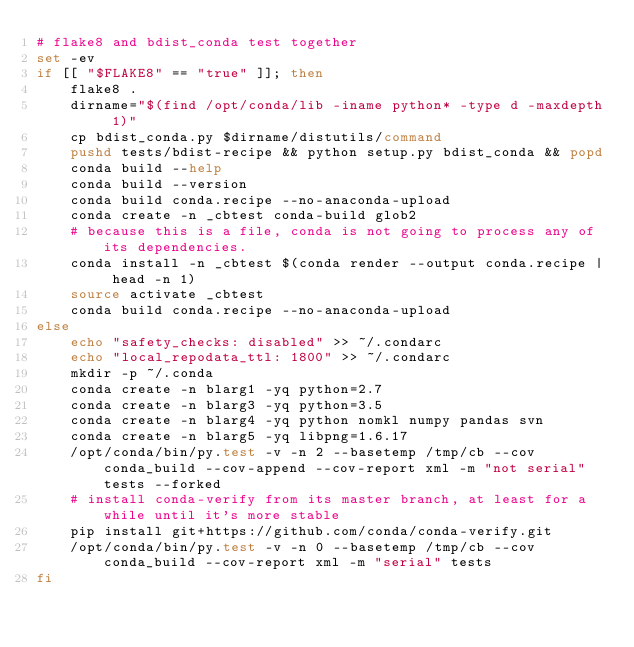Convert code to text. <code><loc_0><loc_0><loc_500><loc_500><_Bash_># flake8 and bdist_conda test together
set -ev
if [[ "$FLAKE8" == "true" ]]; then
    flake8 .
    dirname="$(find /opt/conda/lib -iname python* -type d -maxdepth 1)"
    cp bdist_conda.py $dirname/distutils/command
    pushd tests/bdist-recipe && python setup.py bdist_conda && popd
    conda build --help
    conda build --version
    conda build conda.recipe --no-anaconda-upload
    conda create -n _cbtest conda-build glob2
    # because this is a file, conda is not going to process any of its dependencies.
    conda install -n _cbtest $(conda render --output conda.recipe | head -n 1)
    source activate _cbtest
    conda build conda.recipe --no-anaconda-upload
else
    echo "safety_checks: disabled" >> ~/.condarc
    echo "local_repodata_ttl: 1800" >> ~/.condarc
    mkdir -p ~/.conda
    conda create -n blarg1 -yq python=2.7
    conda create -n blarg3 -yq python=3.5
    conda create -n blarg4 -yq python nomkl numpy pandas svn
    conda create -n blarg5 -yq libpng=1.6.17
    /opt/conda/bin/py.test -v -n 2 --basetemp /tmp/cb --cov conda_build --cov-append --cov-report xml -m "not serial" tests --forked
    # install conda-verify from its master branch, at least for a while until it's more stable
    pip install git+https://github.com/conda/conda-verify.git
    /opt/conda/bin/py.test -v -n 0 --basetemp /tmp/cb --cov conda_build --cov-report xml -m "serial" tests
fi
</code> 